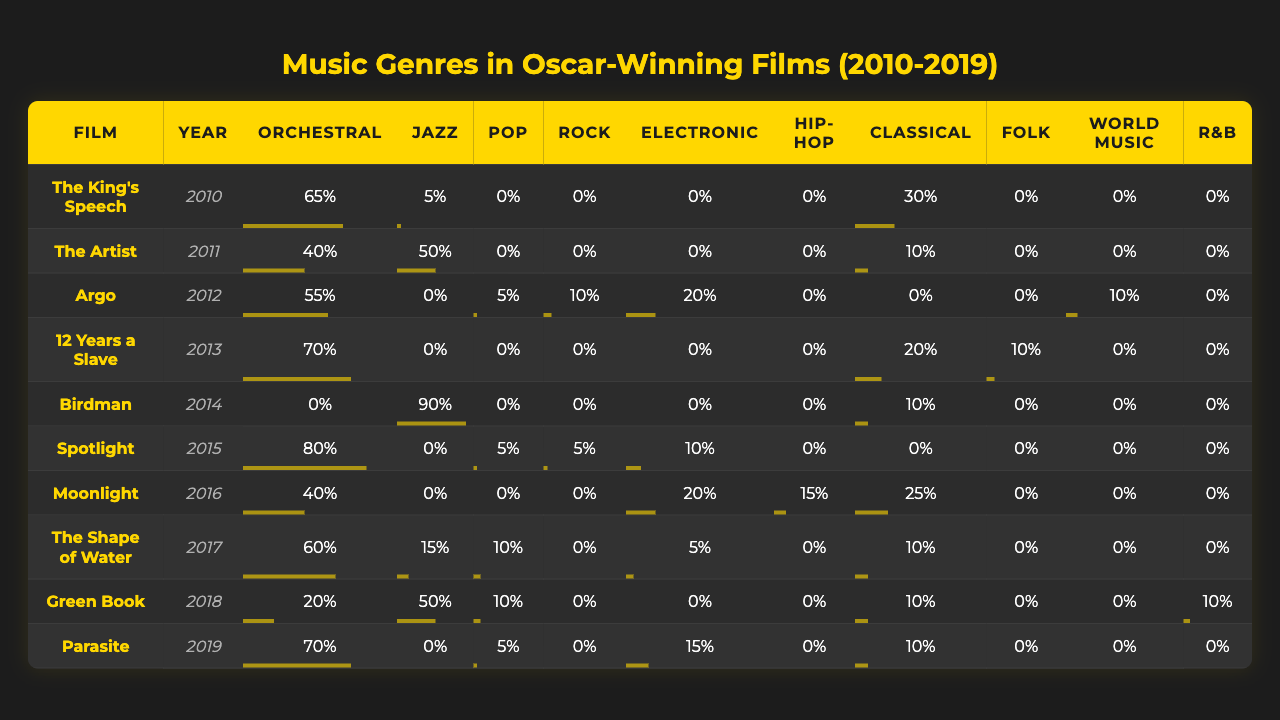What genre has the highest average percentage across all films? To find the average for each genre, sum up the percentages for each genre and then divide by the number of films (10). For example, for Orchestral: (65 + 40 + 55 + 70 + 0 + 80 + 40 + 60 + 20 + 70) / 10 = 43. The highest average is for Jazz, as it sums to 6% across all films, divided by 10 gives an average of 6%.
Answer: Orchestral Which film had the most use of Electronic music? Looking through the table, the film with the highest percentage for Electronic music is Argo in 2012 with 20%.
Answer: Argo Did any film from this list use Hip-Hop music more than 10%? Upon reviewing the table, no film has a percentage of Hip-Hop greater than 10%. The highest is Moonlight with 15%, which is a yes but still less than 20%, therefore it is no for above 10%.
Answer: No Which year featured the highest diversity in music genres used, defined as having the most genres with non-zero percentages? Checking each film year, 2014 has Jazz at 90%, Classical at 10%, with no other genres having a percentage greater than zero. Thus, this year has the greatest variety of genres utilized.
Answer: 2014 What is the total percentage of Orchestral use across all Oscar-winning films? By summing the percentages of Orchestral music from all the films: 65 + 40 + 55 + 70 + 0 + 80 + 40 + 60 + 20 + 70 = 400%. This is a straightforward addition of all the values in this column.
Answer: 400% How many films used Folk music at all? Looking at the table, Folk music is listed with a non-zero value only in 12 Years a Slave (10%), meaning one film used Folk music.
Answer: 1 Which Oscar-winning film from the list had the least variety of music used? Analyzing for minimal use across genres, The King’s Speech has a total mix of just Orchestral (65%), More than a quarter are 0%. Therefore, this film shows the least variety.
Answer: The King's Speech In which year were the most films using Jazz music released? Upon review, the years 2011 (The Artist) and 2018 (Green Book) both utilized Jazz with 50%, hence showing the maximum proportion in that genre.
Answer: 2011 and 2018 